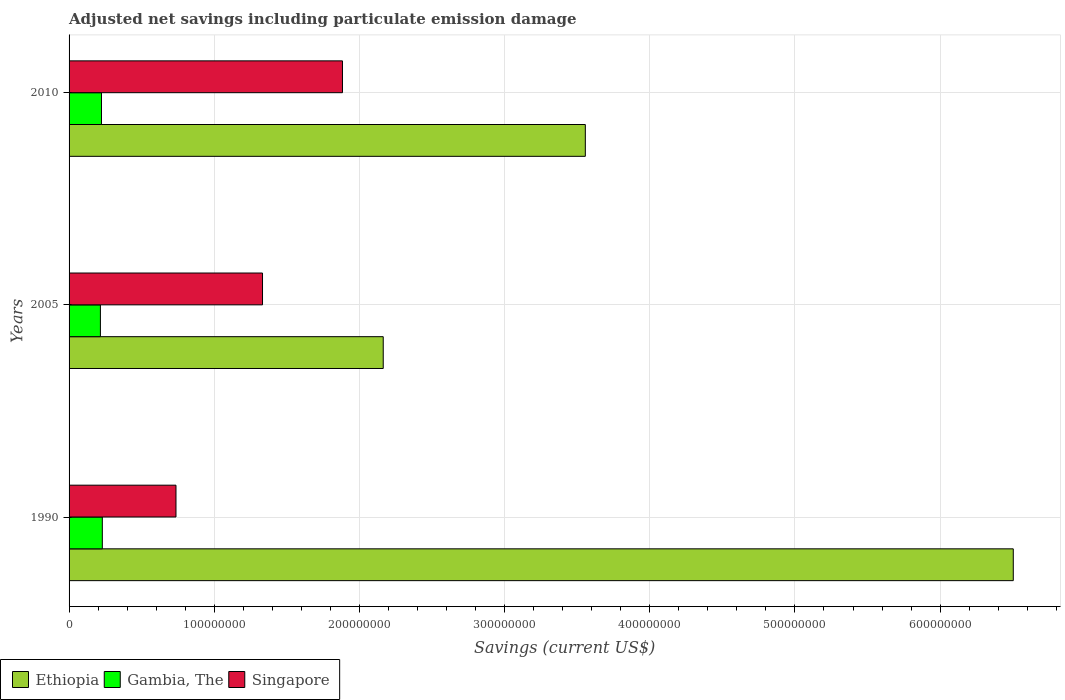How many groups of bars are there?
Your answer should be very brief. 3. Are the number of bars per tick equal to the number of legend labels?
Give a very brief answer. Yes. Are the number of bars on each tick of the Y-axis equal?
Offer a terse response. Yes. How many bars are there on the 2nd tick from the top?
Your answer should be compact. 3. How many bars are there on the 3rd tick from the bottom?
Provide a succinct answer. 3. In how many cases, is the number of bars for a given year not equal to the number of legend labels?
Make the answer very short. 0. What is the net savings in Singapore in 1990?
Provide a succinct answer. 7.36e+07. Across all years, what is the maximum net savings in Ethiopia?
Make the answer very short. 6.50e+08. Across all years, what is the minimum net savings in Singapore?
Your response must be concise. 7.36e+07. In which year was the net savings in Singapore maximum?
Your response must be concise. 2010. In which year was the net savings in Gambia, The minimum?
Provide a succinct answer. 2005. What is the total net savings in Gambia, The in the graph?
Offer a very short reply. 6.68e+07. What is the difference between the net savings in Singapore in 1990 and that in 2010?
Your response must be concise. -1.15e+08. What is the difference between the net savings in Ethiopia in 1990 and the net savings in Gambia, The in 2010?
Your answer should be very brief. 6.28e+08. What is the average net savings in Ethiopia per year?
Make the answer very short. 4.07e+08. In the year 2010, what is the difference between the net savings in Singapore and net savings in Gambia, The?
Your answer should be compact. 1.66e+08. What is the ratio of the net savings in Ethiopia in 2005 to that in 2010?
Your response must be concise. 0.61. Is the net savings in Gambia, The in 2005 less than that in 2010?
Ensure brevity in your answer.  Yes. What is the difference between the highest and the second highest net savings in Ethiopia?
Your answer should be very brief. 2.95e+08. What is the difference between the highest and the lowest net savings in Gambia, The?
Keep it short and to the point. 1.32e+06. What does the 2nd bar from the top in 2005 represents?
Provide a succinct answer. Gambia, The. What does the 3rd bar from the bottom in 1990 represents?
Your answer should be compact. Singapore. Is it the case that in every year, the sum of the net savings in Gambia, The and net savings in Singapore is greater than the net savings in Ethiopia?
Ensure brevity in your answer.  No. How many bars are there?
Provide a short and direct response. 9. Are all the bars in the graph horizontal?
Give a very brief answer. Yes. How many years are there in the graph?
Your answer should be very brief. 3. What is the difference between two consecutive major ticks on the X-axis?
Provide a succinct answer. 1.00e+08. Does the graph contain any zero values?
Offer a terse response. No. Where does the legend appear in the graph?
Provide a succinct answer. Bottom left. How many legend labels are there?
Keep it short and to the point. 3. What is the title of the graph?
Your answer should be compact. Adjusted net savings including particulate emission damage. What is the label or title of the X-axis?
Provide a succinct answer. Savings (current US$). What is the label or title of the Y-axis?
Keep it short and to the point. Years. What is the Savings (current US$) of Ethiopia in 1990?
Provide a short and direct response. 6.50e+08. What is the Savings (current US$) in Gambia, The in 1990?
Offer a very short reply. 2.29e+07. What is the Savings (current US$) of Singapore in 1990?
Give a very brief answer. 7.36e+07. What is the Savings (current US$) in Ethiopia in 2005?
Your response must be concise. 2.16e+08. What is the Savings (current US$) of Gambia, The in 2005?
Ensure brevity in your answer.  2.16e+07. What is the Savings (current US$) in Singapore in 2005?
Make the answer very short. 1.33e+08. What is the Savings (current US$) of Ethiopia in 2010?
Ensure brevity in your answer.  3.56e+08. What is the Savings (current US$) of Gambia, The in 2010?
Offer a terse response. 2.23e+07. What is the Savings (current US$) in Singapore in 2010?
Ensure brevity in your answer.  1.88e+08. Across all years, what is the maximum Savings (current US$) of Ethiopia?
Your response must be concise. 6.50e+08. Across all years, what is the maximum Savings (current US$) in Gambia, The?
Provide a succinct answer. 2.29e+07. Across all years, what is the maximum Savings (current US$) of Singapore?
Ensure brevity in your answer.  1.88e+08. Across all years, what is the minimum Savings (current US$) in Ethiopia?
Keep it short and to the point. 2.16e+08. Across all years, what is the minimum Savings (current US$) in Gambia, The?
Your answer should be compact. 2.16e+07. Across all years, what is the minimum Savings (current US$) in Singapore?
Keep it short and to the point. 7.36e+07. What is the total Savings (current US$) in Ethiopia in the graph?
Give a very brief answer. 1.22e+09. What is the total Savings (current US$) of Gambia, The in the graph?
Give a very brief answer. 6.68e+07. What is the total Savings (current US$) of Singapore in the graph?
Offer a terse response. 3.95e+08. What is the difference between the Savings (current US$) in Ethiopia in 1990 and that in 2005?
Make the answer very short. 4.34e+08. What is the difference between the Savings (current US$) of Gambia, The in 1990 and that in 2005?
Your answer should be very brief. 1.32e+06. What is the difference between the Savings (current US$) of Singapore in 1990 and that in 2005?
Provide a succinct answer. -5.96e+07. What is the difference between the Savings (current US$) of Ethiopia in 1990 and that in 2010?
Your answer should be very brief. 2.95e+08. What is the difference between the Savings (current US$) in Gambia, The in 1990 and that in 2010?
Give a very brief answer. 5.78e+05. What is the difference between the Savings (current US$) of Singapore in 1990 and that in 2010?
Offer a very short reply. -1.15e+08. What is the difference between the Savings (current US$) of Ethiopia in 2005 and that in 2010?
Give a very brief answer. -1.39e+08. What is the difference between the Savings (current US$) in Gambia, The in 2005 and that in 2010?
Give a very brief answer. -7.39e+05. What is the difference between the Savings (current US$) in Singapore in 2005 and that in 2010?
Provide a short and direct response. -5.51e+07. What is the difference between the Savings (current US$) of Ethiopia in 1990 and the Savings (current US$) of Gambia, The in 2005?
Your response must be concise. 6.29e+08. What is the difference between the Savings (current US$) of Ethiopia in 1990 and the Savings (current US$) of Singapore in 2005?
Keep it short and to the point. 5.17e+08. What is the difference between the Savings (current US$) of Gambia, The in 1990 and the Savings (current US$) of Singapore in 2005?
Provide a short and direct response. -1.10e+08. What is the difference between the Savings (current US$) in Ethiopia in 1990 and the Savings (current US$) in Gambia, The in 2010?
Provide a succinct answer. 6.28e+08. What is the difference between the Savings (current US$) in Ethiopia in 1990 and the Savings (current US$) in Singapore in 2010?
Give a very brief answer. 4.62e+08. What is the difference between the Savings (current US$) of Gambia, The in 1990 and the Savings (current US$) of Singapore in 2010?
Provide a short and direct response. -1.65e+08. What is the difference between the Savings (current US$) in Ethiopia in 2005 and the Savings (current US$) in Gambia, The in 2010?
Make the answer very short. 1.94e+08. What is the difference between the Savings (current US$) in Ethiopia in 2005 and the Savings (current US$) in Singapore in 2010?
Offer a very short reply. 2.81e+07. What is the difference between the Savings (current US$) in Gambia, The in 2005 and the Savings (current US$) in Singapore in 2010?
Your answer should be very brief. -1.67e+08. What is the average Savings (current US$) in Ethiopia per year?
Give a very brief answer. 4.07e+08. What is the average Savings (current US$) of Gambia, The per year?
Your response must be concise. 2.23e+07. What is the average Savings (current US$) of Singapore per year?
Keep it short and to the point. 1.32e+08. In the year 1990, what is the difference between the Savings (current US$) of Ethiopia and Savings (current US$) of Gambia, The?
Provide a succinct answer. 6.27e+08. In the year 1990, what is the difference between the Savings (current US$) of Ethiopia and Savings (current US$) of Singapore?
Give a very brief answer. 5.77e+08. In the year 1990, what is the difference between the Savings (current US$) in Gambia, The and Savings (current US$) in Singapore?
Your answer should be very brief. -5.07e+07. In the year 2005, what is the difference between the Savings (current US$) in Ethiopia and Savings (current US$) in Gambia, The?
Make the answer very short. 1.95e+08. In the year 2005, what is the difference between the Savings (current US$) of Ethiopia and Savings (current US$) of Singapore?
Give a very brief answer. 8.32e+07. In the year 2005, what is the difference between the Savings (current US$) in Gambia, The and Savings (current US$) in Singapore?
Give a very brief answer. -1.12e+08. In the year 2010, what is the difference between the Savings (current US$) of Ethiopia and Savings (current US$) of Gambia, The?
Give a very brief answer. 3.33e+08. In the year 2010, what is the difference between the Savings (current US$) in Ethiopia and Savings (current US$) in Singapore?
Offer a terse response. 1.67e+08. In the year 2010, what is the difference between the Savings (current US$) in Gambia, The and Savings (current US$) in Singapore?
Keep it short and to the point. -1.66e+08. What is the ratio of the Savings (current US$) of Ethiopia in 1990 to that in 2005?
Your response must be concise. 3.01. What is the ratio of the Savings (current US$) of Gambia, The in 1990 to that in 2005?
Ensure brevity in your answer.  1.06. What is the ratio of the Savings (current US$) in Singapore in 1990 to that in 2005?
Your answer should be very brief. 0.55. What is the ratio of the Savings (current US$) in Ethiopia in 1990 to that in 2010?
Your response must be concise. 1.83. What is the ratio of the Savings (current US$) in Gambia, The in 1990 to that in 2010?
Give a very brief answer. 1.03. What is the ratio of the Savings (current US$) in Singapore in 1990 to that in 2010?
Make the answer very short. 0.39. What is the ratio of the Savings (current US$) of Ethiopia in 2005 to that in 2010?
Keep it short and to the point. 0.61. What is the ratio of the Savings (current US$) in Gambia, The in 2005 to that in 2010?
Keep it short and to the point. 0.97. What is the ratio of the Savings (current US$) of Singapore in 2005 to that in 2010?
Your answer should be very brief. 0.71. What is the difference between the highest and the second highest Savings (current US$) of Ethiopia?
Offer a terse response. 2.95e+08. What is the difference between the highest and the second highest Savings (current US$) in Gambia, The?
Ensure brevity in your answer.  5.78e+05. What is the difference between the highest and the second highest Savings (current US$) in Singapore?
Provide a succinct answer. 5.51e+07. What is the difference between the highest and the lowest Savings (current US$) of Ethiopia?
Provide a short and direct response. 4.34e+08. What is the difference between the highest and the lowest Savings (current US$) in Gambia, The?
Your answer should be very brief. 1.32e+06. What is the difference between the highest and the lowest Savings (current US$) in Singapore?
Provide a short and direct response. 1.15e+08. 